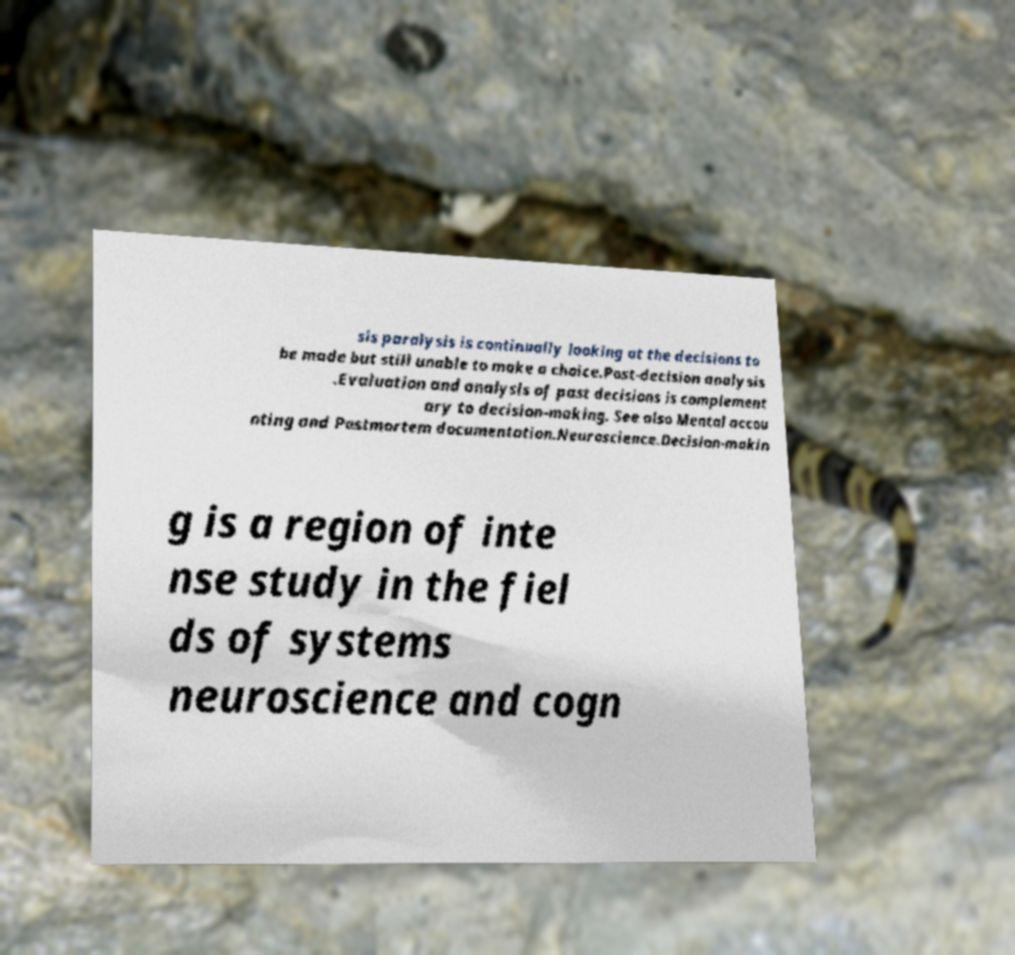I need the written content from this picture converted into text. Can you do that? sis paralysis is continually looking at the decisions to be made but still unable to make a choice.Post-decision analysis .Evaluation and analysis of past decisions is complement ary to decision-making. See also Mental accou nting and Postmortem documentation.Neuroscience.Decision-makin g is a region of inte nse study in the fiel ds of systems neuroscience and cogn 